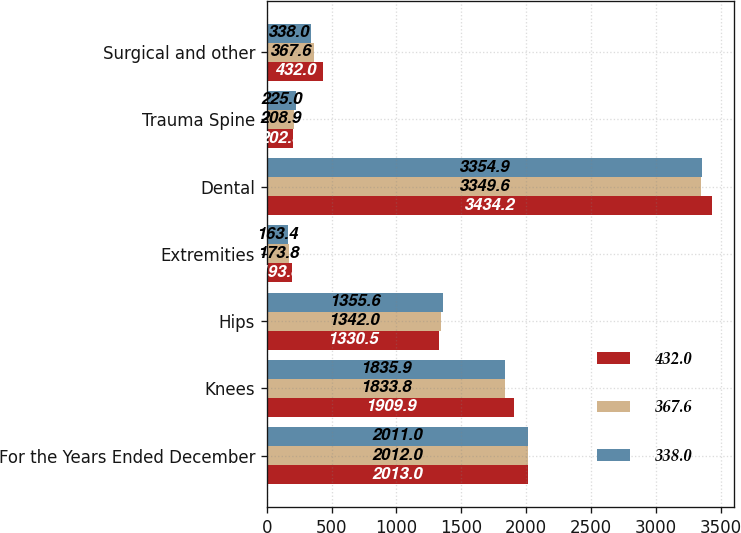<chart> <loc_0><loc_0><loc_500><loc_500><stacked_bar_chart><ecel><fcel>For the Years Ended December<fcel>Knees<fcel>Hips<fcel>Extremities<fcel>Dental<fcel>Trauma Spine<fcel>Surgical and other<nl><fcel>432<fcel>2013<fcel>1909.9<fcel>1330.5<fcel>193.8<fcel>3434.2<fcel>202.3<fcel>432<nl><fcel>367.6<fcel>2012<fcel>1833.8<fcel>1342<fcel>173.8<fcel>3349.6<fcel>208.9<fcel>367.6<nl><fcel>338<fcel>2011<fcel>1835.9<fcel>1355.6<fcel>163.4<fcel>3354.9<fcel>225<fcel>338<nl></chart> 